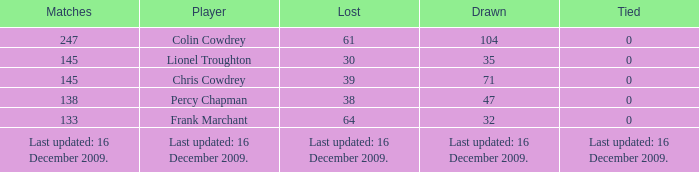What is the tie that resulted in a 71 draw? 0.0. 